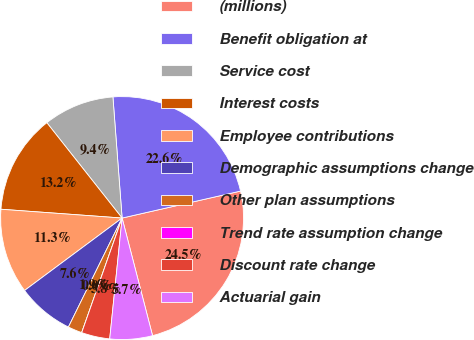Convert chart to OTSL. <chart><loc_0><loc_0><loc_500><loc_500><pie_chart><fcel>(millions)<fcel>Benefit obligation at<fcel>Service cost<fcel>Interest costs<fcel>Employee contributions<fcel>Demographic assumptions change<fcel>Other plan assumptions<fcel>Trend rate assumption change<fcel>Discount rate change<fcel>Actuarial gain<nl><fcel>24.53%<fcel>22.64%<fcel>9.43%<fcel>13.21%<fcel>11.32%<fcel>7.55%<fcel>1.89%<fcel>0.0%<fcel>3.77%<fcel>5.66%<nl></chart> 